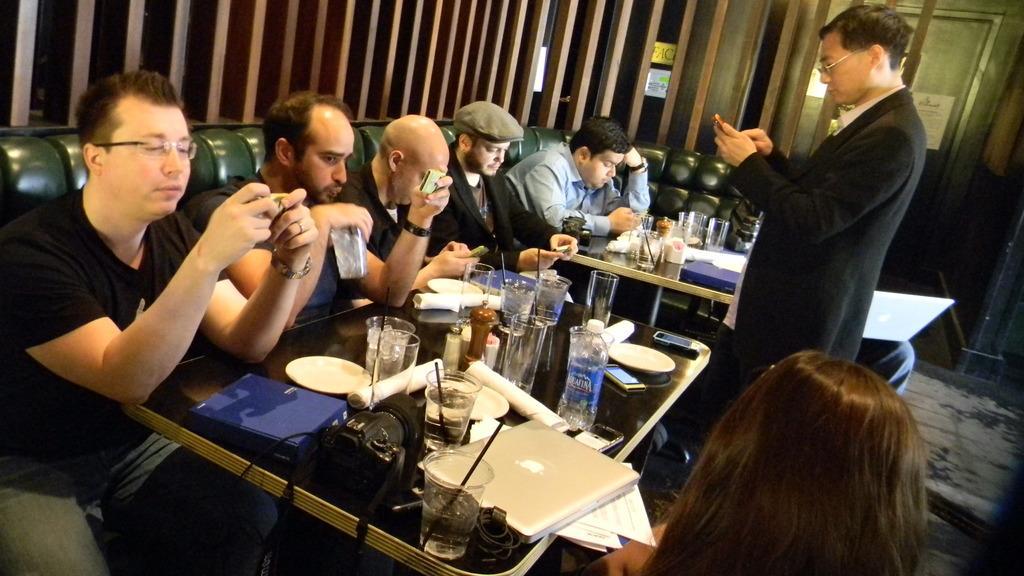Can you describe this image briefly? This image is clicked inside a room. There are sofas and tables. On that table there are glasses, laptops, papers, phones, tissues, cameras. 